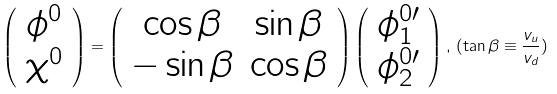Convert formula to latex. <formula><loc_0><loc_0><loc_500><loc_500>\left ( \begin{array} { c } \phi ^ { 0 } \\ \chi ^ { 0 } \end{array} \right ) = \left ( \begin{array} { c c } \cos \beta & \sin \beta \\ - \sin \beta & \cos \beta \end{array} \right ) \left ( \begin{array} { c } \phi ^ { 0 \prime } _ { 1 } \\ \phi ^ { 0 \prime } _ { 2 } \end{array} \right ) , \, ( \tan \beta \equiv \frac { v _ { u } } { v _ { d } } )</formula> 